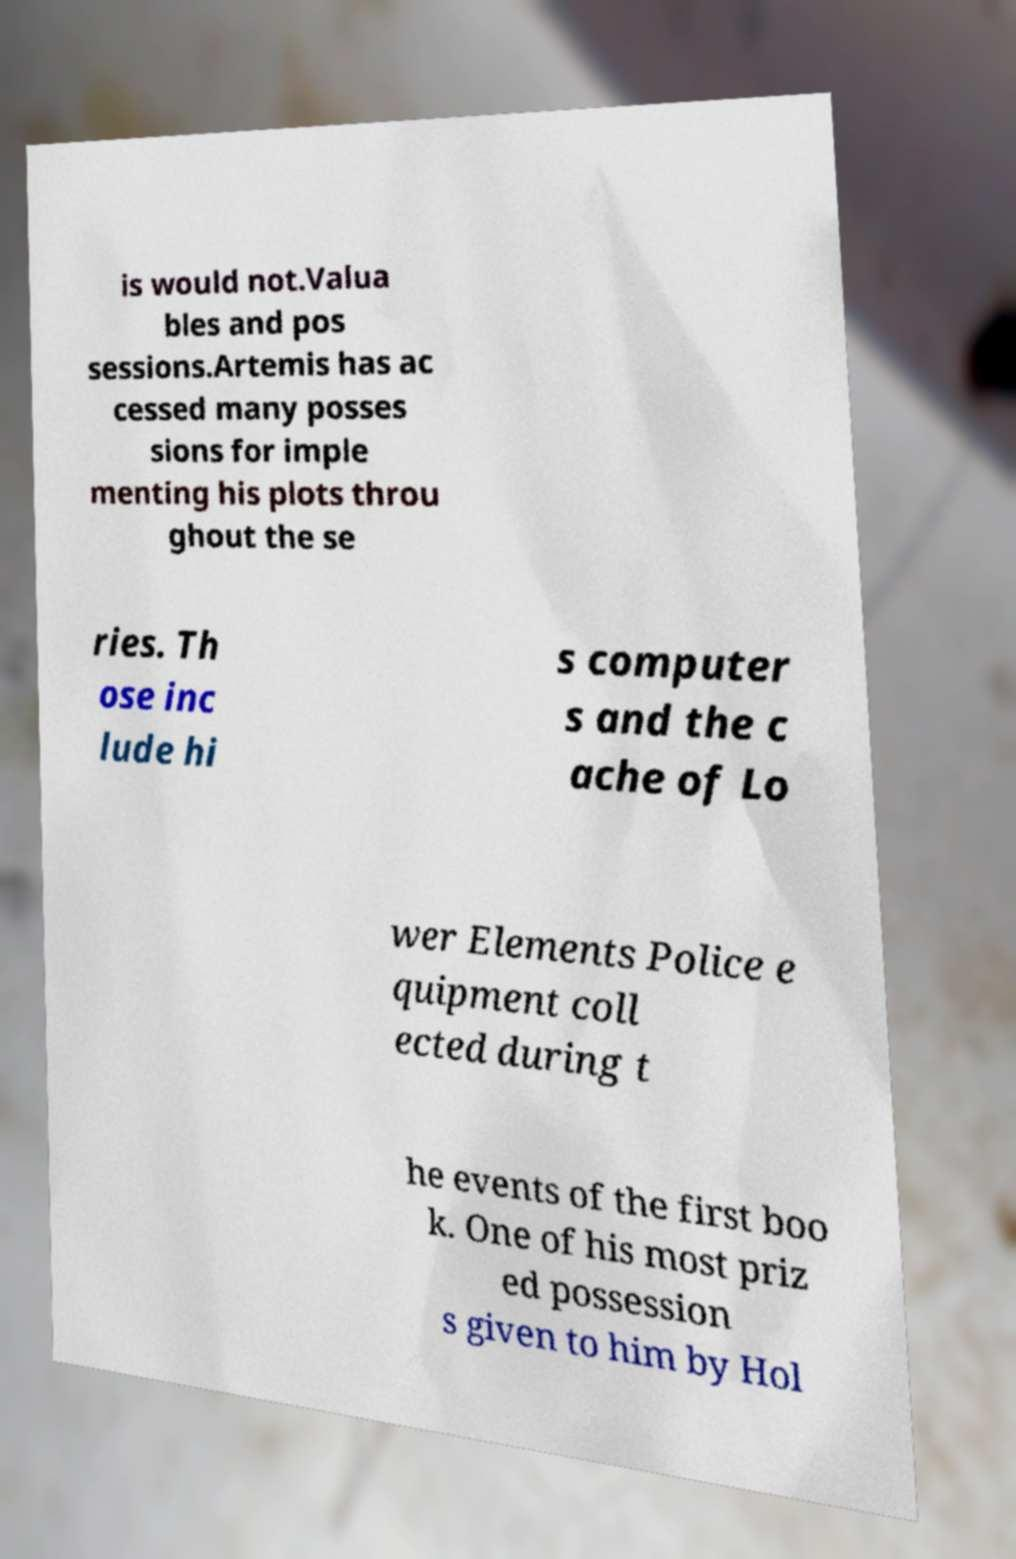There's text embedded in this image that I need extracted. Can you transcribe it verbatim? is would not.Valua bles and pos sessions.Artemis has ac cessed many posses sions for imple menting his plots throu ghout the se ries. Th ose inc lude hi s computer s and the c ache of Lo wer Elements Police e quipment coll ected during t he events of the first boo k. One of his most priz ed possession s given to him by Hol 